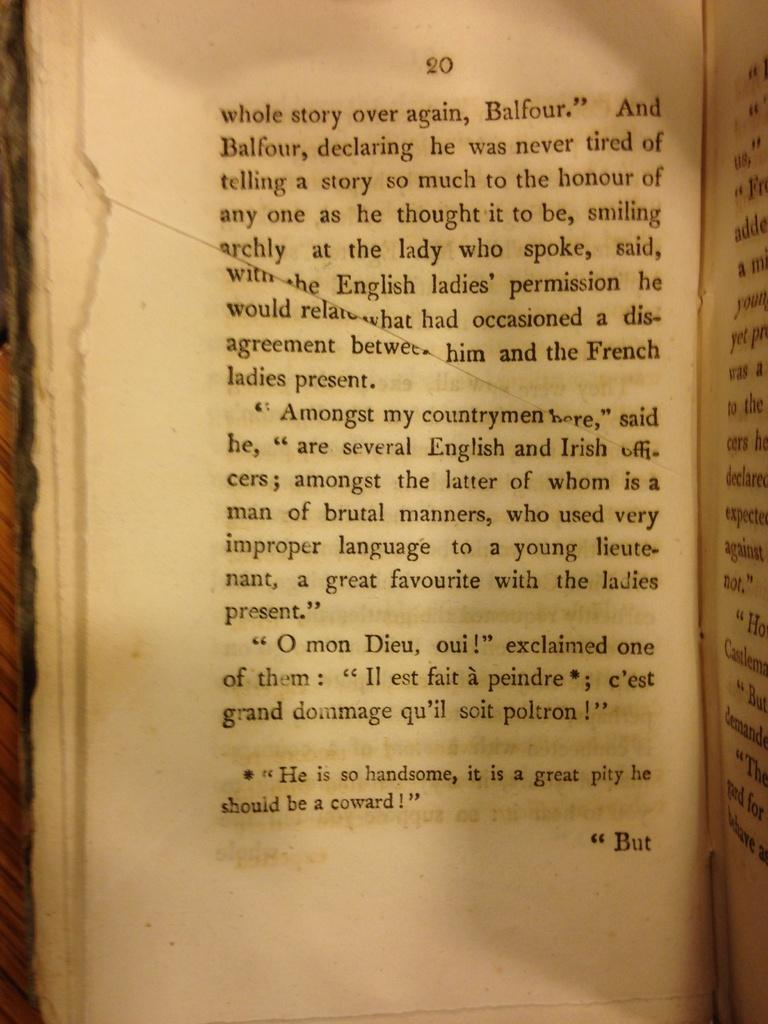<image>
Summarize the visual content of the image. A book with torn pages is open to page twenty. 